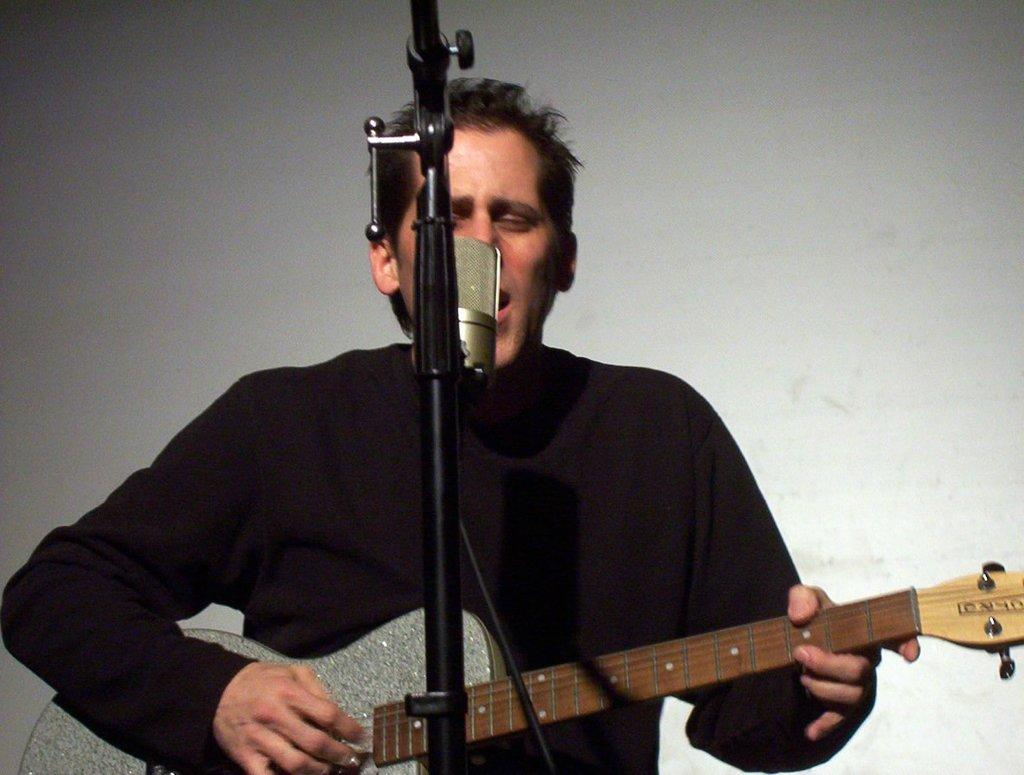What is the person in the image doing? The person is playing the guitar. What object is the person holding while playing the guitar? The person is holding a guitar. Where is the person positioned in relation to the microphone? The person is in front of a microphone. What color is the t-shirt the person is wearing? The person is wearing a black t-shirt. What is the color of the background in the image? The background of the image is ash in color. Can you tell me the reason the girl is holding a dime in the image? There is no girl or dime present in the image; it features a person playing the guitar in front of a microphone. 